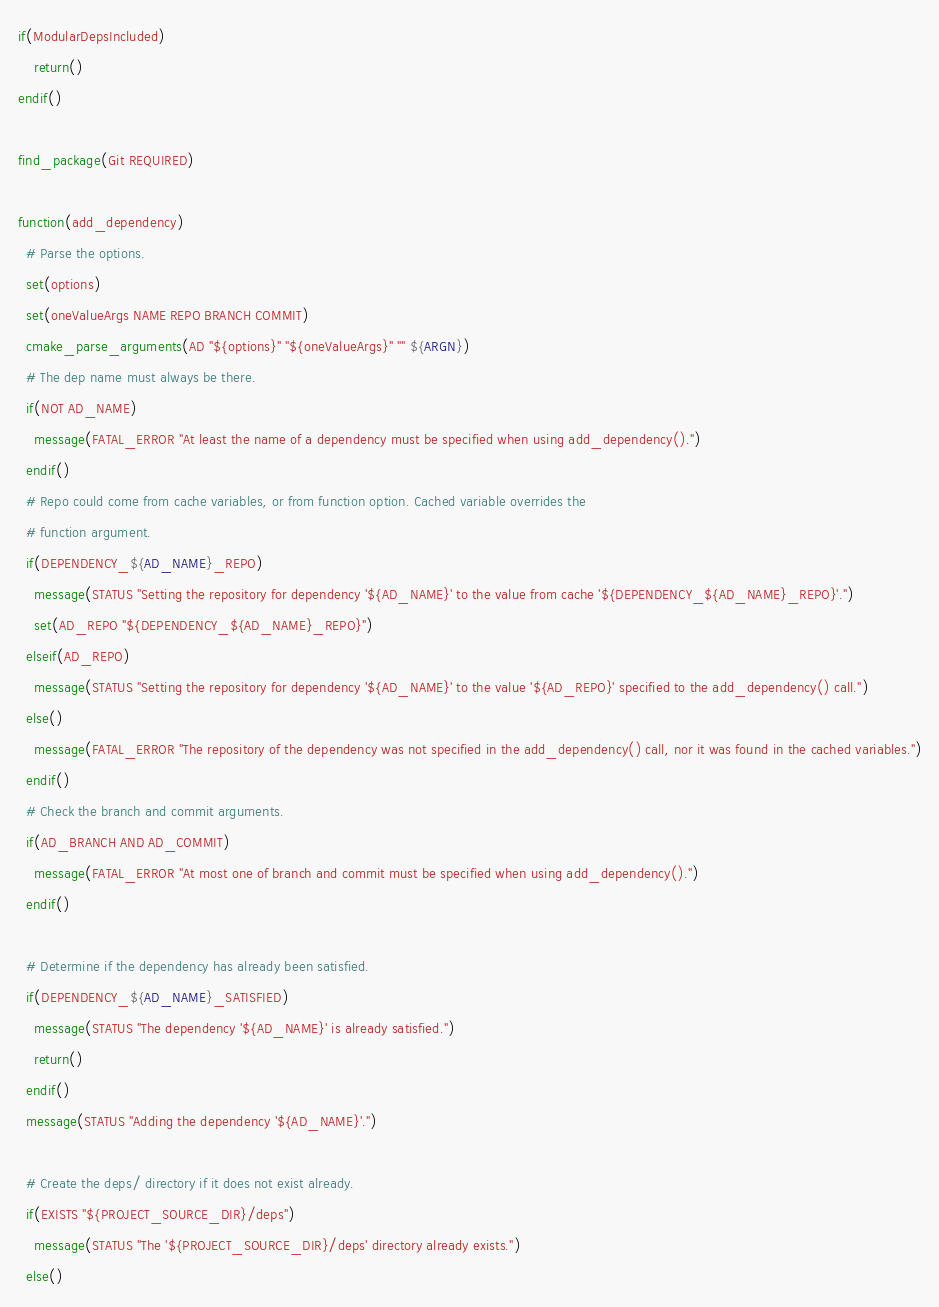Convert code to text. <code><loc_0><loc_0><loc_500><loc_500><_CMake_>if(ModularDepsIncluded)
    return()
endif()

find_package(Git REQUIRED)

function(add_dependency)
  # Parse the options.
  set(options)
  set(oneValueArgs NAME REPO BRANCH COMMIT)
  cmake_parse_arguments(AD "${options}" "${oneValueArgs}" "" ${ARGN})
  # The dep name must always be there.
  if(NOT AD_NAME)
    message(FATAL_ERROR "At least the name of a dependency must be specified when using add_dependency().")
  endif()
  # Repo could come from cache variables, or from function option. Cached variable overrides the
  # function argument.
  if(DEPENDENCY_${AD_NAME}_REPO)
    message(STATUS "Setting the repository for dependency '${AD_NAME}' to the value from cache '${DEPENDENCY_${AD_NAME}_REPO}'.")
    set(AD_REPO "${DEPENDENCY_${AD_NAME}_REPO}")
  elseif(AD_REPO)
    message(STATUS "Setting the repository for dependency '${AD_NAME}' to the value '${AD_REPO}' specified to the add_dependency() call.")
  else()
    message(FATAL_ERROR "The repository of the dependency was not specified in the add_dependency() call, nor it was found in the cached variables.")
  endif()
  # Check the branch and commit arguments.
  if(AD_BRANCH AND AD_COMMIT)
    message(FATAL_ERROR "At most one of branch and commit must be specified when using add_dependency().")
  endif()

  # Determine if the dependency has already been satisfied.
  if(DEPENDENCY_${AD_NAME}_SATISFIED)
    message(STATUS "The dependency '${AD_NAME}' is already satisfied.")
    return()
  endif()
  message(STATUS "Adding the dependency '${AD_NAME}'.")

  # Create the deps/ directory if it does not exist already.
  if(EXISTS "${PROJECT_SOURCE_DIR}/deps")
    message(STATUS "The '${PROJECT_SOURCE_DIR}/deps' directory already exists.")
  else()</code> 